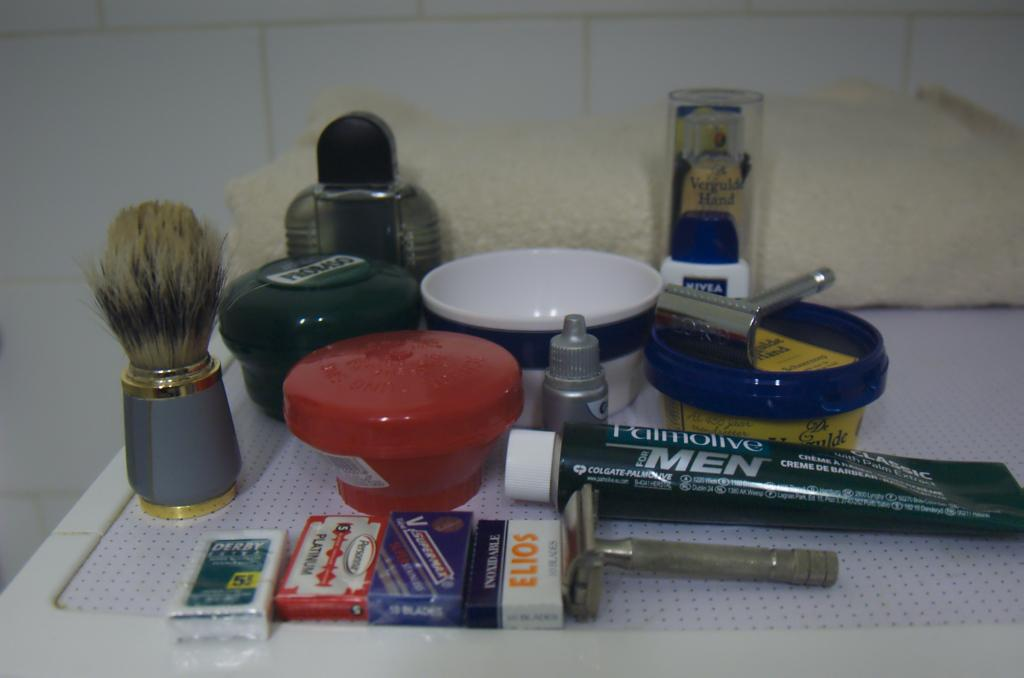Provide a one-sentence caption for the provided image. A tube of Palmolive for Men is placed with other shaving things. 